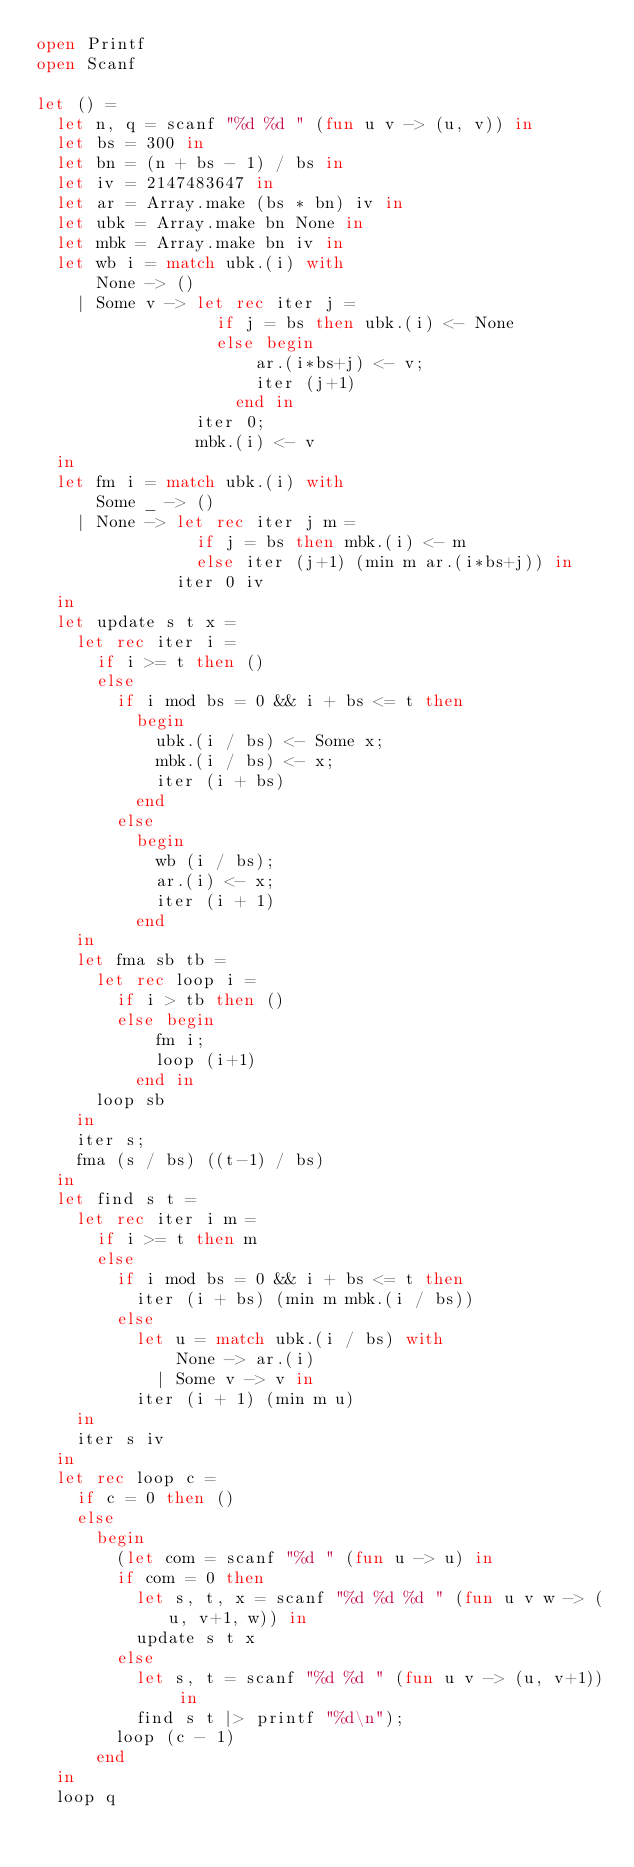<code> <loc_0><loc_0><loc_500><loc_500><_OCaml_>open Printf
open Scanf

let () =
  let n, q = scanf "%d %d " (fun u v -> (u, v)) in
  let bs = 300 in
  let bn = (n + bs - 1) / bs in
  let iv = 2147483647 in
  let ar = Array.make (bs * bn) iv in
  let ubk = Array.make bn None in
  let mbk = Array.make bn iv in
  let wb i = match ubk.(i) with
      None -> ()
    | Some v -> let rec iter j =
                  if j = bs then ubk.(i) <- None
                  else begin
                      ar.(i*bs+j) <- v;
                      iter (j+1)
                    end in
                iter 0;
                mbk.(i) <- v
  in
  let fm i = match ubk.(i) with
      Some _ -> ()
    | None -> let rec iter j m =
                if j = bs then mbk.(i) <- m
                else iter (j+1) (min m ar.(i*bs+j)) in
              iter 0 iv
  in
  let update s t x =
    let rec iter i =
      if i >= t then ()
      else
        if i mod bs = 0 && i + bs <= t then
          begin
            ubk.(i / bs) <- Some x;
            mbk.(i / bs) <- x;
            iter (i + bs)
          end
        else
          begin
            wb (i / bs);
            ar.(i) <- x;
            iter (i + 1)
          end
    in
    let fma sb tb =
      let rec loop i =
        if i > tb then ()
        else begin
            fm i;
            loop (i+1)
          end in
      loop sb
    in
    iter s;
    fma (s / bs) ((t-1) / bs)
  in
  let find s t =
    let rec iter i m =
      if i >= t then m
      else
        if i mod bs = 0 && i + bs <= t then
          iter (i + bs) (min m mbk.(i / bs))
        else
          let u = match ubk.(i / bs) with
              None -> ar.(i)
            | Some v -> v in
          iter (i + 1) (min m u)
    in
    iter s iv
  in
  let rec loop c =
    if c = 0 then ()
    else
      begin
        (let com = scanf "%d " (fun u -> u) in
        if com = 0 then
          let s, t, x = scanf "%d %d %d " (fun u v w -> (u, v+1, w)) in
          update s t x
        else
          let s, t = scanf "%d %d " (fun u v -> (u, v+1)) in
          find s t |> printf "%d\n");
        loop (c - 1)
      end
  in
  loop q</code> 